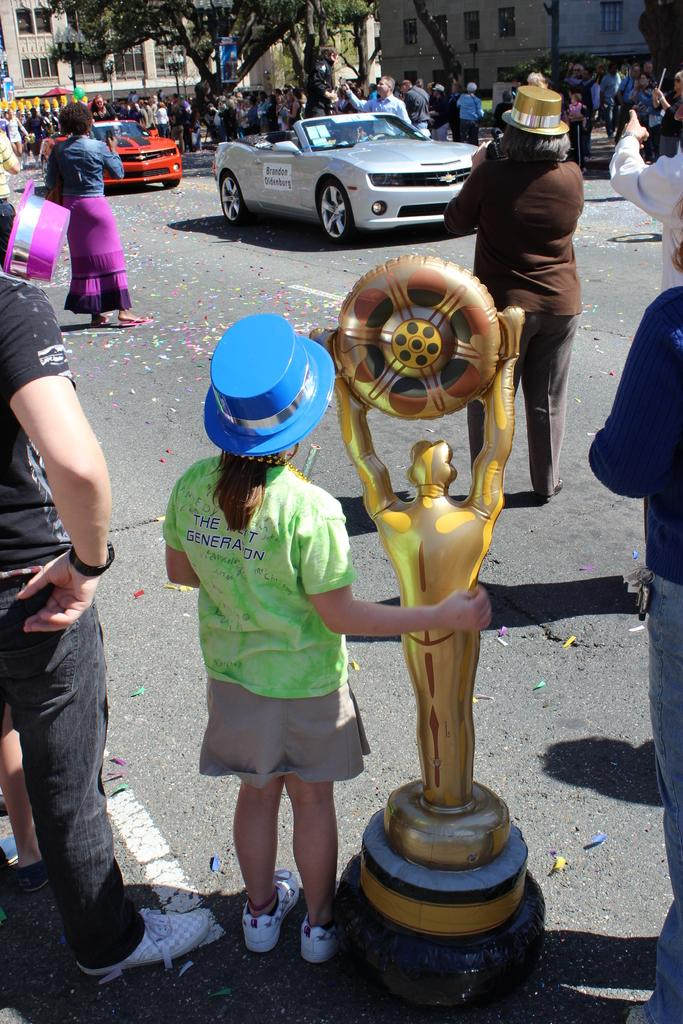What is happening on the road in the image? Vehicles are on the road in the image. What is the girl holding in the image? The girl is holding a trophy in the image. What can be seen near the vehicles in the image? There are people near the vehicles in the image. What type of structures are visible in the image? There are buildings with windows in the image. What is located in front of a building in the image? There is a tree in front of a building in the image. What type of secretary is sitting under the tree in the image? There is no secretary present in the image; it features vehicles on the road, a girl holding a trophy, people near the vehicles, buildings with windows, and a tree in front of a building. What type of pickle is being used as a prop in the image? There is no pickle present in the image. 